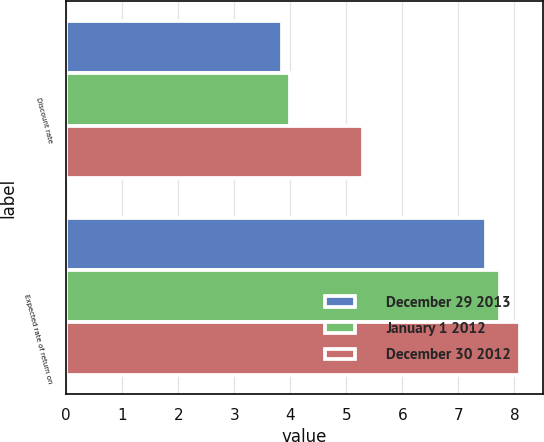Convert chart to OTSL. <chart><loc_0><loc_0><loc_500><loc_500><stacked_bar_chart><ecel><fcel>Discount rate<fcel>Expected rate of return on<nl><fcel>December 29 2013<fcel>3.86<fcel>7.5<nl><fcel>January 1 2012<fcel>4<fcel>7.75<nl><fcel>December 30 2012<fcel>5.3<fcel>8.1<nl></chart> 